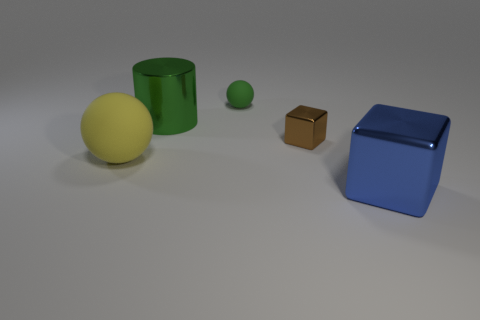What materials are the objects made of, and can you identify them? The objects seem to be made of various materials. The yellow sphere and small green object look like they're made of rubber, the blue object appears to be glossy plastic, and the small brown cube looks like cardboard.  How is the lighting affecting the appearance of the objects? The lighting is coming from above and its diffused nature minimizes harsh shadows, while emphasizing the textures and colors of the objects. The glossy surface of the blue cube and green cylinder reflects more light, giving them a shinier appearance compared to the matte yellow sphere and the small brown cube. 